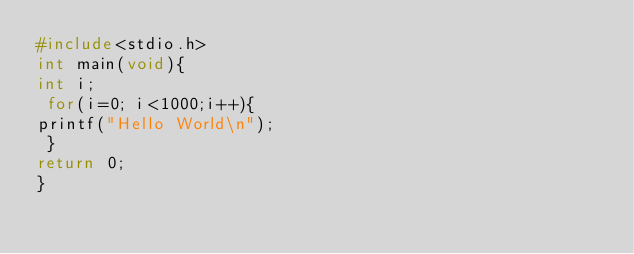<code> <loc_0><loc_0><loc_500><loc_500><_C_>#include<stdio.h> 
int main(void){ 
int i;
 for(i=0; i<1000;i++){ 
printf("Hello World\n");
 }
return 0; 
} </code> 